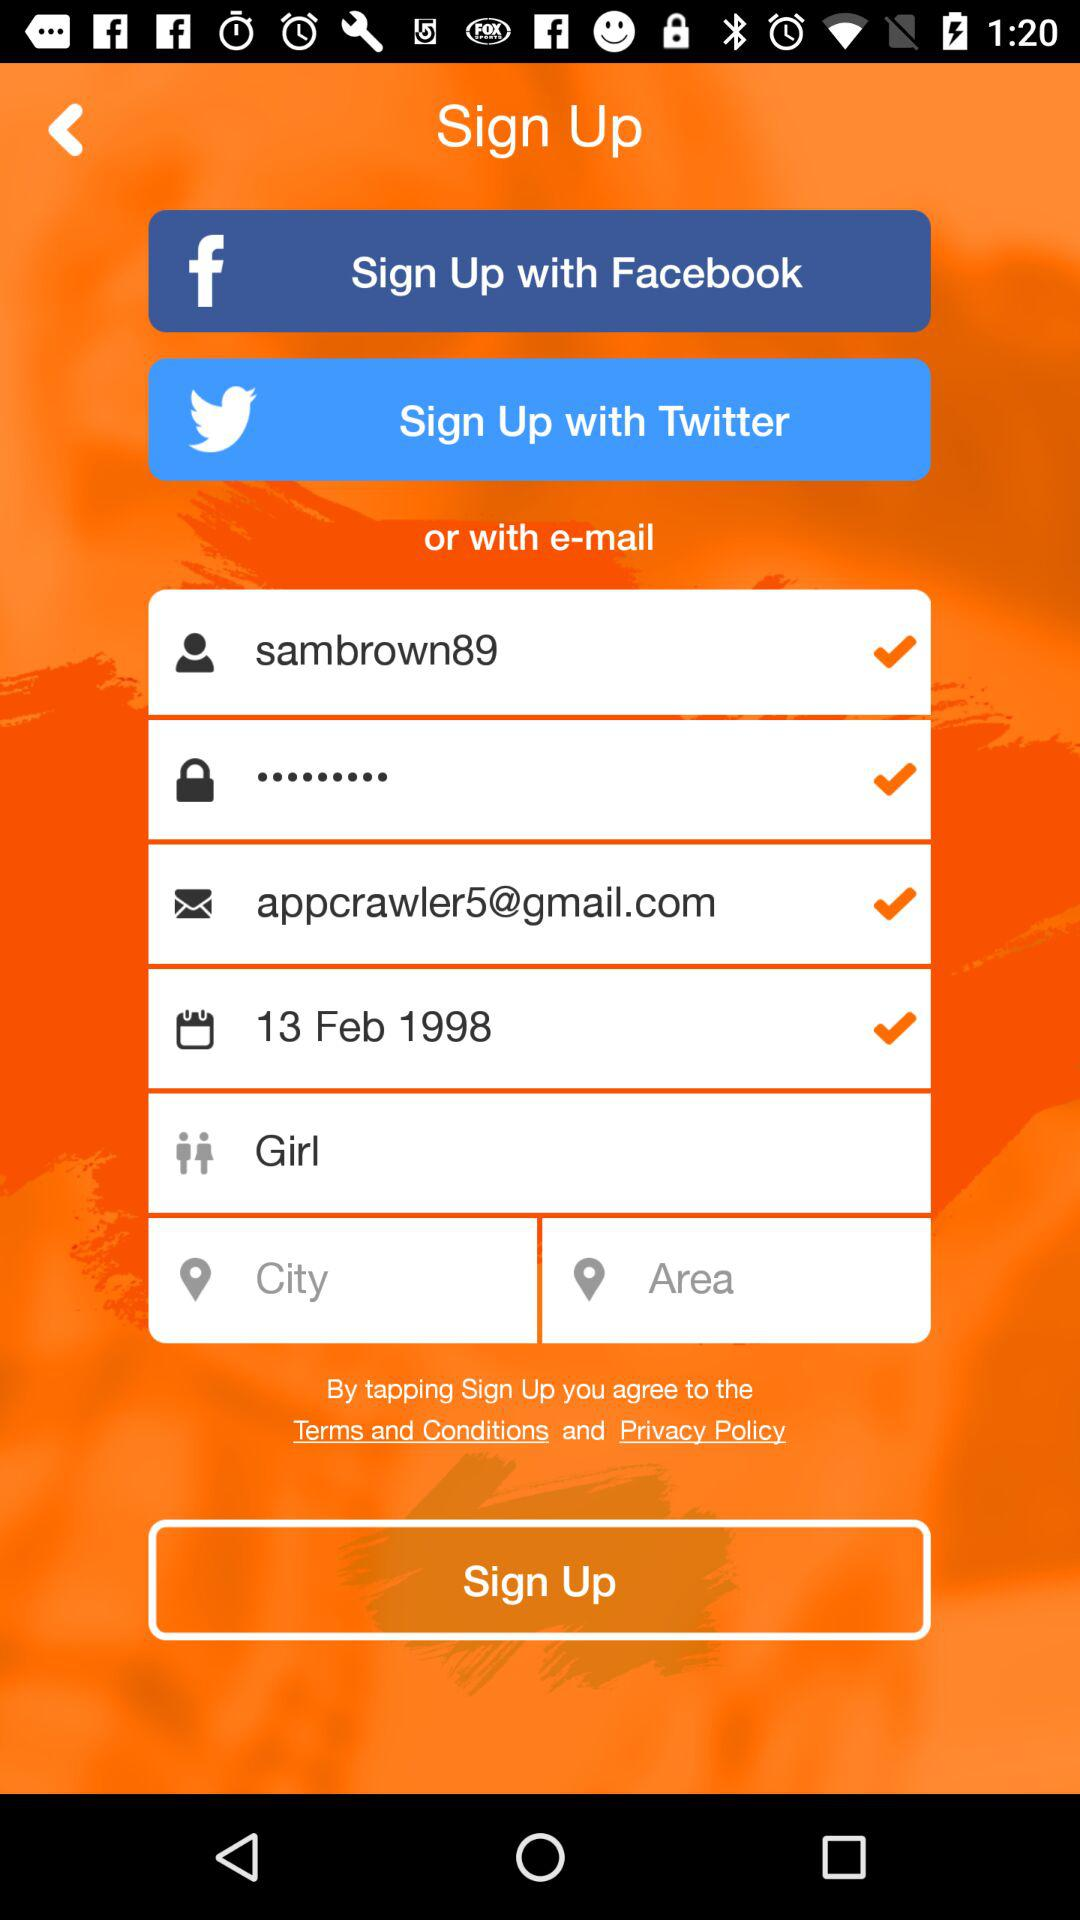What application can I use to sign up? The applications are "Facebook" and "Twitter". 